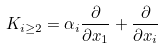<formula> <loc_0><loc_0><loc_500><loc_500>K _ { i \geq 2 } = \alpha _ { i } \frac { \partial } { \partial x _ { 1 } } + \frac { \partial } { \partial x _ { i } }</formula> 